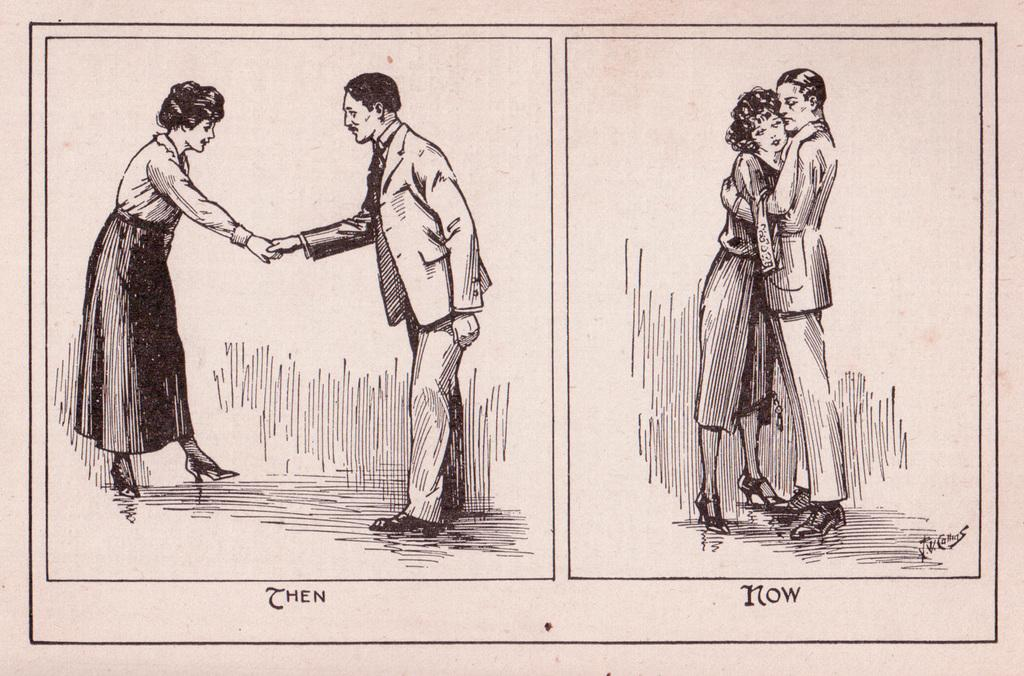What is the main subject of the image? The main subject of the image is a drawing. What can be seen in the drawing? There are persons in the drawing. Is there any text present in the image? Yes, there is text in the image. What is the color of the background in the image? The background of the image is white in color. What type of noise can be heard coming from the sponge in the image? There is no sponge present in the image, and therefore no noise can be heard from it. What material is the plastic object made of in the image? There is no plastic object present in the image. 